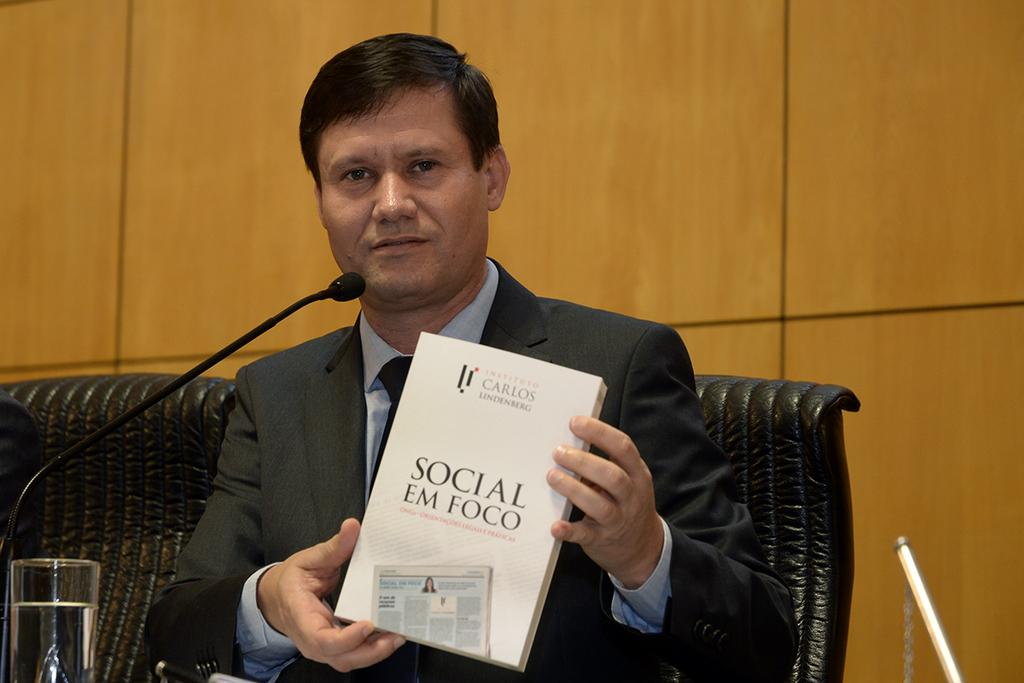<image>
Present a compact description of the photo's key features. A man in a suit in front of a microphone holding a book titled Social Em Foco. 